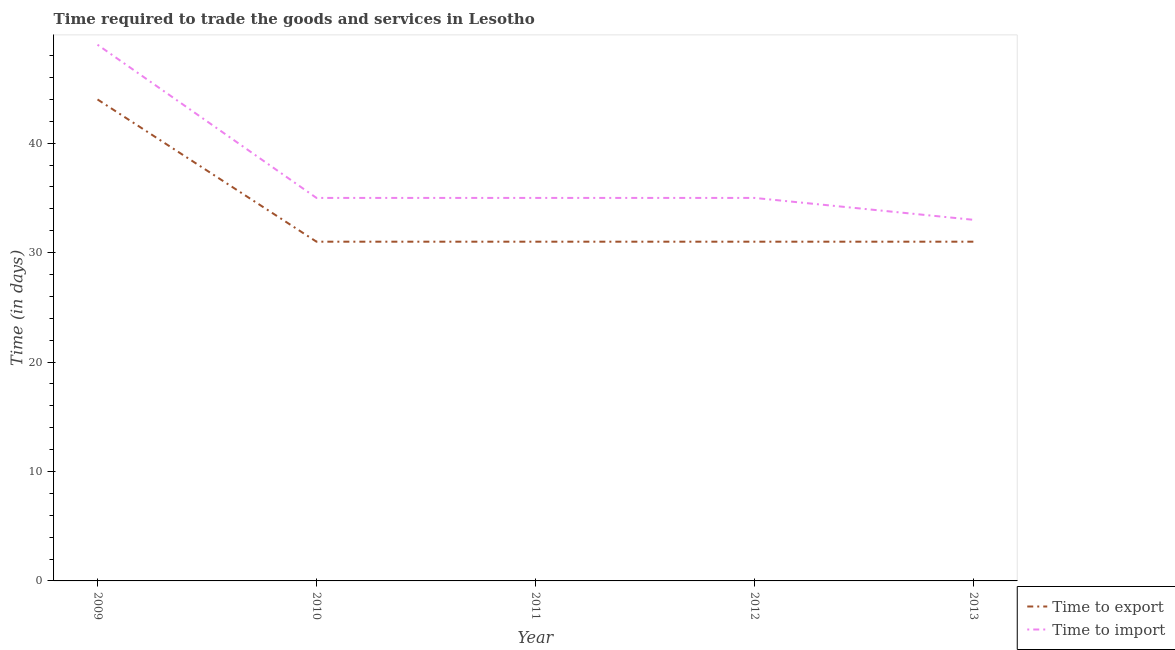How many different coloured lines are there?
Offer a very short reply. 2. Is the number of lines equal to the number of legend labels?
Make the answer very short. Yes. What is the time to export in 2010?
Give a very brief answer. 31. Across all years, what is the maximum time to import?
Keep it short and to the point. 49. Across all years, what is the minimum time to import?
Your answer should be compact. 33. What is the total time to import in the graph?
Your answer should be compact. 187. What is the difference between the time to export in 2009 and that in 2012?
Offer a terse response. 13. What is the difference between the time to export in 2013 and the time to import in 2009?
Provide a short and direct response. -18. What is the average time to import per year?
Keep it short and to the point. 37.4. In the year 2009, what is the difference between the time to export and time to import?
Your response must be concise. -5. In how many years, is the time to import greater than 44 days?
Keep it short and to the point. 1. What is the ratio of the time to export in 2009 to that in 2013?
Ensure brevity in your answer.  1.42. Is the difference between the time to export in 2010 and 2013 greater than the difference between the time to import in 2010 and 2013?
Offer a very short reply. No. What is the difference between the highest and the lowest time to import?
Provide a succinct answer. 16. Is the sum of the time to import in 2012 and 2013 greater than the maximum time to export across all years?
Your answer should be very brief. Yes. Does the time to import monotonically increase over the years?
Make the answer very short. No. How many lines are there?
Offer a terse response. 2. Are the values on the major ticks of Y-axis written in scientific E-notation?
Offer a very short reply. No. Does the graph contain any zero values?
Provide a short and direct response. No. How many legend labels are there?
Your answer should be compact. 2. How are the legend labels stacked?
Make the answer very short. Vertical. What is the title of the graph?
Your answer should be very brief. Time required to trade the goods and services in Lesotho. What is the label or title of the Y-axis?
Provide a succinct answer. Time (in days). What is the Time (in days) in Time to export in 2009?
Ensure brevity in your answer.  44. What is the Time (in days) of Time to import in 2010?
Provide a succinct answer. 35. What is the Time (in days) of Time to import in 2011?
Provide a succinct answer. 35. What is the Time (in days) in Time to export in 2012?
Provide a short and direct response. 31. What is the Time (in days) of Time to export in 2013?
Offer a very short reply. 31. What is the Time (in days) of Time to import in 2013?
Your answer should be compact. 33. Across all years, what is the minimum Time (in days) in Time to export?
Give a very brief answer. 31. Across all years, what is the minimum Time (in days) in Time to import?
Your answer should be compact. 33. What is the total Time (in days) of Time to export in the graph?
Keep it short and to the point. 168. What is the total Time (in days) of Time to import in the graph?
Make the answer very short. 187. What is the difference between the Time (in days) in Time to export in 2009 and that in 2010?
Your answer should be very brief. 13. What is the difference between the Time (in days) in Time to import in 2009 and that in 2010?
Make the answer very short. 14. What is the difference between the Time (in days) of Time to export in 2009 and that in 2011?
Make the answer very short. 13. What is the difference between the Time (in days) in Time to export in 2009 and that in 2012?
Offer a terse response. 13. What is the difference between the Time (in days) of Time to import in 2009 and that in 2013?
Keep it short and to the point. 16. What is the difference between the Time (in days) of Time to import in 2010 and that in 2011?
Keep it short and to the point. 0. What is the difference between the Time (in days) in Time to export in 2010 and that in 2012?
Offer a very short reply. 0. What is the difference between the Time (in days) of Time to export in 2010 and that in 2013?
Your response must be concise. 0. What is the difference between the Time (in days) in Time to export in 2011 and that in 2012?
Your answer should be very brief. 0. What is the difference between the Time (in days) in Time to import in 2011 and that in 2012?
Your answer should be very brief. 0. What is the difference between the Time (in days) of Time to export in 2012 and that in 2013?
Give a very brief answer. 0. What is the difference between the Time (in days) in Time to import in 2012 and that in 2013?
Ensure brevity in your answer.  2. What is the difference between the Time (in days) of Time to export in 2009 and the Time (in days) of Time to import in 2010?
Make the answer very short. 9. What is the difference between the Time (in days) of Time to export in 2009 and the Time (in days) of Time to import in 2013?
Provide a succinct answer. 11. What is the difference between the Time (in days) in Time to export in 2010 and the Time (in days) in Time to import in 2011?
Provide a short and direct response. -4. What is the difference between the Time (in days) in Time to export in 2010 and the Time (in days) in Time to import in 2012?
Offer a very short reply. -4. What is the difference between the Time (in days) of Time to export in 2012 and the Time (in days) of Time to import in 2013?
Ensure brevity in your answer.  -2. What is the average Time (in days) of Time to export per year?
Make the answer very short. 33.6. What is the average Time (in days) of Time to import per year?
Offer a very short reply. 37.4. In the year 2010, what is the difference between the Time (in days) of Time to export and Time (in days) of Time to import?
Offer a terse response. -4. In the year 2011, what is the difference between the Time (in days) in Time to export and Time (in days) in Time to import?
Keep it short and to the point. -4. In the year 2012, what is the difference between the Time (in days) in Time to export and Time (in days) in Time to import?
Your answer should be compact. -4. What is the ratio of the Time (in days) of Time to export in 2009 to that in 2010?
Provide a succinct answer. 1.42. What is the ratio of the Time (in days) in Time to export in 2009 to that in 2011?
Give a very brief answer. 1.42. What is the ratio of the Time (in days) in Time to import in 2009 to that in 2011?
Make the answer very short. 1.4. What is the ratio of the Time (in days) of Time to export in 2009 to that in 2012?
Your answer should be compact. 1.42. What is the ratio of the Time (in days) in Time to export in 2009 to that in 2013?
Your answer should be compact. 1.42. What is the ratio of the Time (in days) of Time to import in 2009 to that in 2013?
Ensure brevity in your answer.  1.48. What is the ratio of the Time (in days) in Time to import in 2010 to that in 2012?
Make the answer very short. 1. What is the ratio of the Time (in days) of Time to import in 2010 to that in 2013?
Provide a short and direct response. 1.06. What is the ratio of the Time (in days) in Time to export in 2011 to that in 2012?
Keep it short and to the point. 1. What is the ratio of the Time (in days) of Time to import in 2011 to that in 2012?
Provide a succinct answer. 1. What is the ratio of the Time (in days) of Time to export in 2011 to that in 2013?
Provide a short and direct response. 1. What is the ratio of the Time (in days) of Time to import in 2011 to that in 2013?
Provide a succinct answer. 1.06. What is the ratio of the Time (in days) of Time to import in 2012 to that in 2013?
Your response must be concise. 1.06. What is the difference between the highest and the lowest Time (in days) in Time to import?
Ensure brevity in your answer.  16. 